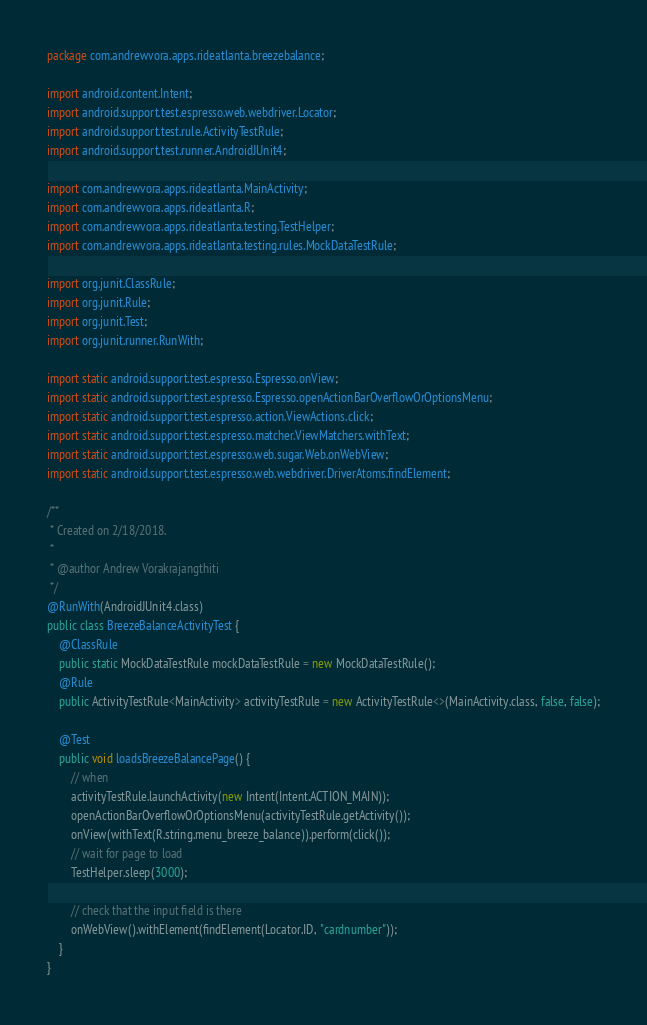<code> <loc_0><loc_0><loc_500><loc_500><_Java_>package com.andrewvora.apps.rideatlanta.breezebalance;

import android.content.Intent;
import android.support.test.espresso.web.webdriver.Locator;
import android.support.test.rule.ActivityTestRule;
import android.support.test.runner.AndroidJUnit4;

import com.andrewvora.apps.rideatlanta.MainActivity;
import com.andrewvora.apps.rideatlanta.R;
import com.andrewvora.apps.rideatlanta.testing.TestHelper;
import com.andrewvora.apps.rideatlanta.testing.rules.MockDataTestRule;

import org.junit.ClassRule;
import org.junit.Rule;
import org.junit.Test;
import org.junit.runner.RunWith;

import static android.support.test.espresso.Espresso.onView;
import static android.support.test.espresso.Espresso.openActionBarOverflowOrOptionsMenu;
import static android.support.test.espresso.action.ViewActions.click;
import static android.support.test.espresso.matcher.ViewMatchers.withText;
import static android.support.test.espresso.web.sugar.Web.onWebView;
import static android.support.test.espresso.web.webdriver.DriverAtoms.findElement;

/**
 * Created on 2/18/2018.
 *
 * @author Andrew Vorakrajangthiti
 */
@RunWith(AndroidJUnit4.class)
public class BreezeBalanceActivityTest {
	@ClassRule
	public static MockDataTestRule mockDataTestRule = new MockDataTestRule();
	@Rule
	public ActivityTestRule<MainActivity> activityTestRule = new ActivityTestRule<>(MainActivity.class, false, false);

	@Test
	public void loadsBreezeBalancePage() {
		// when
		activityTestRule.launchActivity(new Intent(Intent.ACTION_MAIN));
		openActionBarOverflowOrOptionsMenu(activityTestRule.getActivity());
		onView(withText(R.string.menu_breeze_balance)).perform(click());
		// wait for page to load
		TestHelper.sleep(3000);

		// check that the input field is there
		onWebView().withElement(findElement(Locator.ID, "cardnumber"));
	}
}</code> 